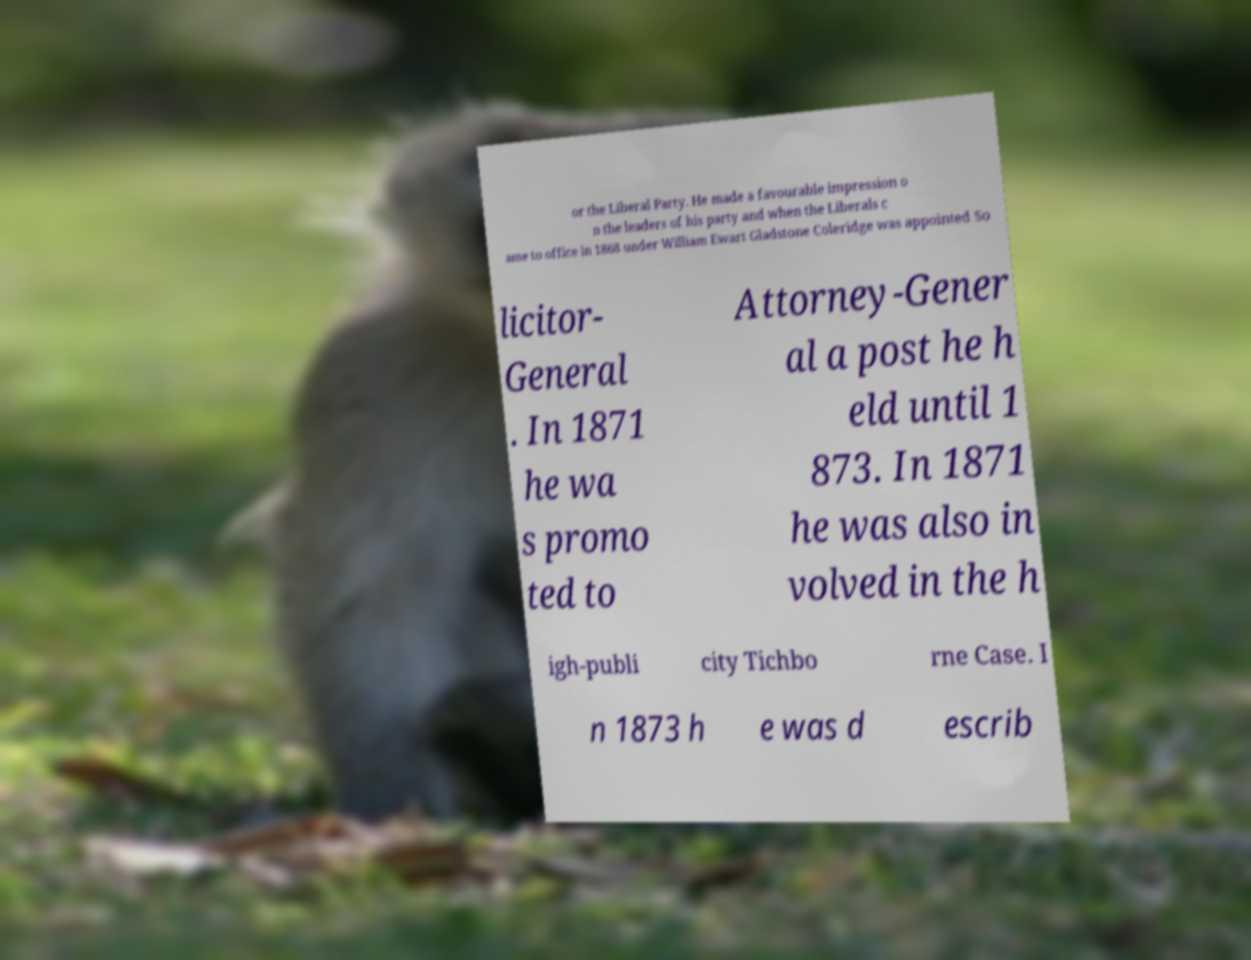Please read and relay the text visible in this image. What does it say? or the Liberal Party. He made a favourable impression o n the leaders of his party and when the Liberals c ame to office in 1868 under William Ewart Gladstone Coleridge was appointed So licitor- General . In 1871 he wa s promo ted to Attorney-Gener al a post he h eld until 1 873. In 1871 he was also in volved in the h igh-publi city Tichbo rne Case. I n 1873 h e was d escrib 